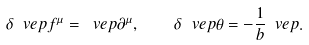<formula> <loc_0><loc_0><loc_500><loc_500>\delta _ { \ } v e p f ^ { \mu } = \ v e p \partial ^ { \mu } , \quad \delta _ { \ } v e p \theta = - \frac { 1 } { b } \ v e p .</formula> 